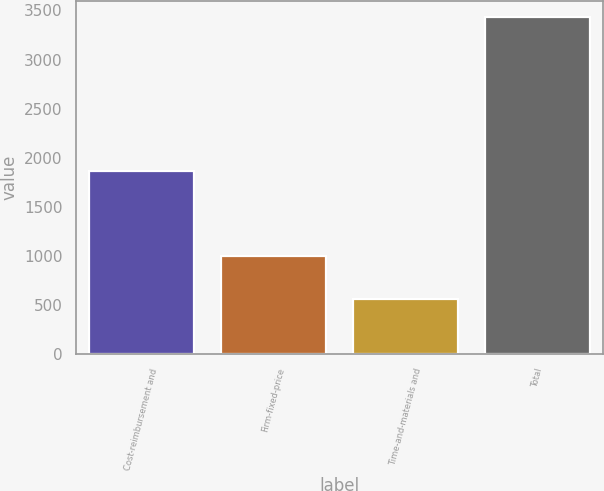Convert chart. <chart><loc_0><loc_0><loc_500><loc_500><bar_chart><fcel>Cost-reimbursement and<fcel>Firm-fixed-price<fcel>Time-and-materials and<fcel>Total<nl><fcel>1863<fcel>1004<fcel>562<fcel>3429<nl></chart> 